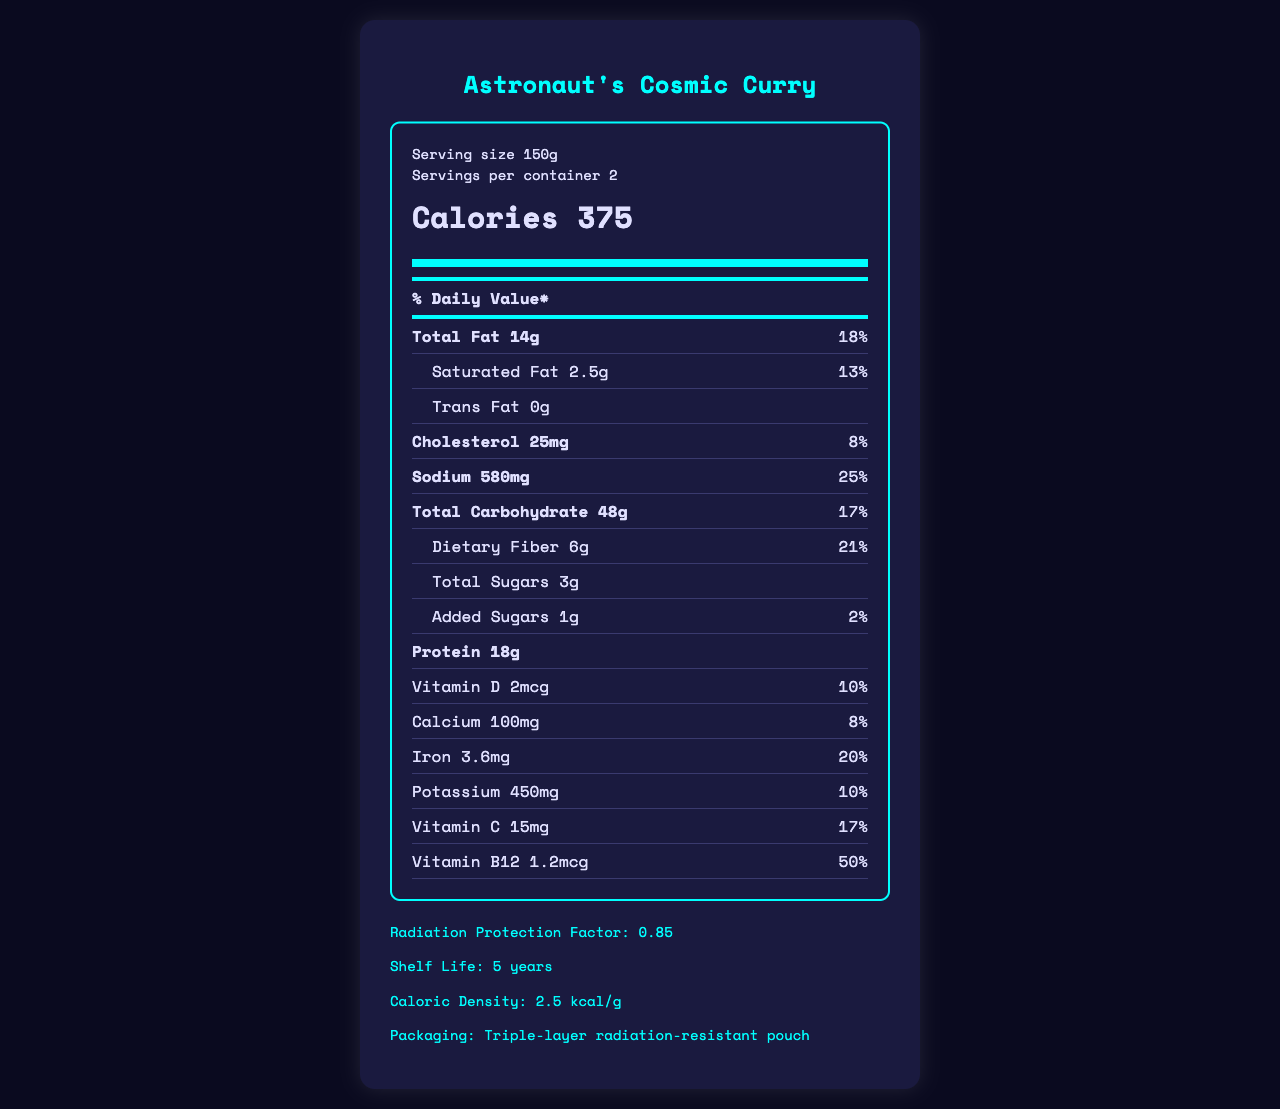what is the serving size of Astronaut's Cosmic Curry? The serving size is mentioned clearly at the top of the nutrition label as 150g.
Answer: 150g how many servings are there in one container? The nutrition label indicates that there are 2 servings per container.
Answer: 2 how many calories are in one serving of Astronaut's Cosmic Curry? The calorie content per serving is written in bold within the calorie info section as 375 calories.
Answer: 375 calories what is the amount of total fat in one serving, and what percentage of the daily value does it represent? The total fat content is listed as 14g, which represents 18% of the daily value, as indicated in the nutrient row for "Total Fat".
Answer: 14g, 18% how much protein is in one serving of Astronaut's Cosmic Curry? The protein content is listed in the nutrient row for "Protein" as 18g.
Answer: 18g how much sodium is in one serving, and what percentage of the daily value does it represent? A. 480mg, 20% B. 580mg, 25% C. 620mg, 30% D. 450mg, 18% The sodium content in one serving is listed as 580mg, which represents 25% of the daily value.
Answer: B which of the following nutrients has the highest daily value percentage per serving? A. Vitamin D B. Calcium C. Iron D. Vitamin C Iron has the highest daily value percentage at 20%, followed by Vitamin C at 17%, Vitamin D at 10%, and Calcium at 8%.
Answer: C does Astronaut's Cosmic Curry contain any trans fat? The trans fat content is indicated as 0g in the sub-nutrient row for "Trans Fat".
Answer: No is there any added sugar in Astronaut's Cosmic Curry? The nutrition label lists 1g of added sugars, which represents 2% of the daily value.
Answer: Yes please describe the entire document's main idea. The document is a comprehensive nutrition facts label designed for a dehydrated meal intended for space missions. It details the product's name, serving size, calorie count, and nutrient information, such as amounts and daily values of fats, cholesterol, sodium, carbohydrates, proteins, and vitamins. The label also includes specialized information related to space travel, such as cosmic radiation considerations and nutrient stability.
Answer: The document provides a detailed nutrition label for "Astronaut's Cosmic Curry," including information on serving size, caloric content, and daily values of various nutrients. It highlights the meal's macronutrient distribution, caloric density, and specific considerations for space missions, such as radiation protection factors and packaging details. what is the vitamin C daily value percentage per serving? The daily value percentage for Vitamin C is listed as 17% in the nutrient row for "Vitamin C".
Answer: 17% what is the caloric density of Astronaut's Cosmic Curry per gram? The caloric density is explicitly mentioned in the space info section as 2.5 kcal/g.
Answer: 2.5 kcal/g what type of packaging is used for Astronaut's Cosmic Curry? The packaging detail provided in the space info section specifies a "Triple-layer radiation-resistant pouch."
Answer: Triple-layer radiation-resistant pouch how many grams of dietary fiber are in one serving? The dietary fiber content per serving is listed as 6g in the sub-nutrient row for "Dietary Fiber".
Answer: 6g based on the nutrient information, can you determine the exact amount of Vitamin A in one serving? The document does not provide any information about the amount of Vitamin A in one serving; it is not listed among the nutrients.
Answer: Cannot be determined 